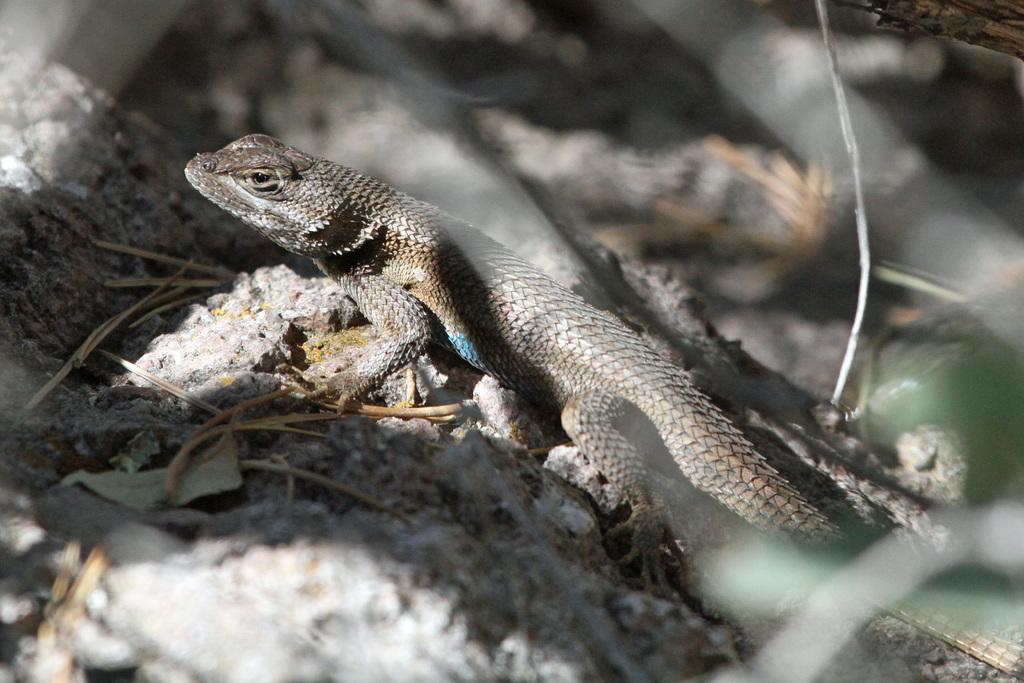Can you describe this image briefly? In the center of the image, we can see a garden lizard and in the background, there are stones and some twigs. 